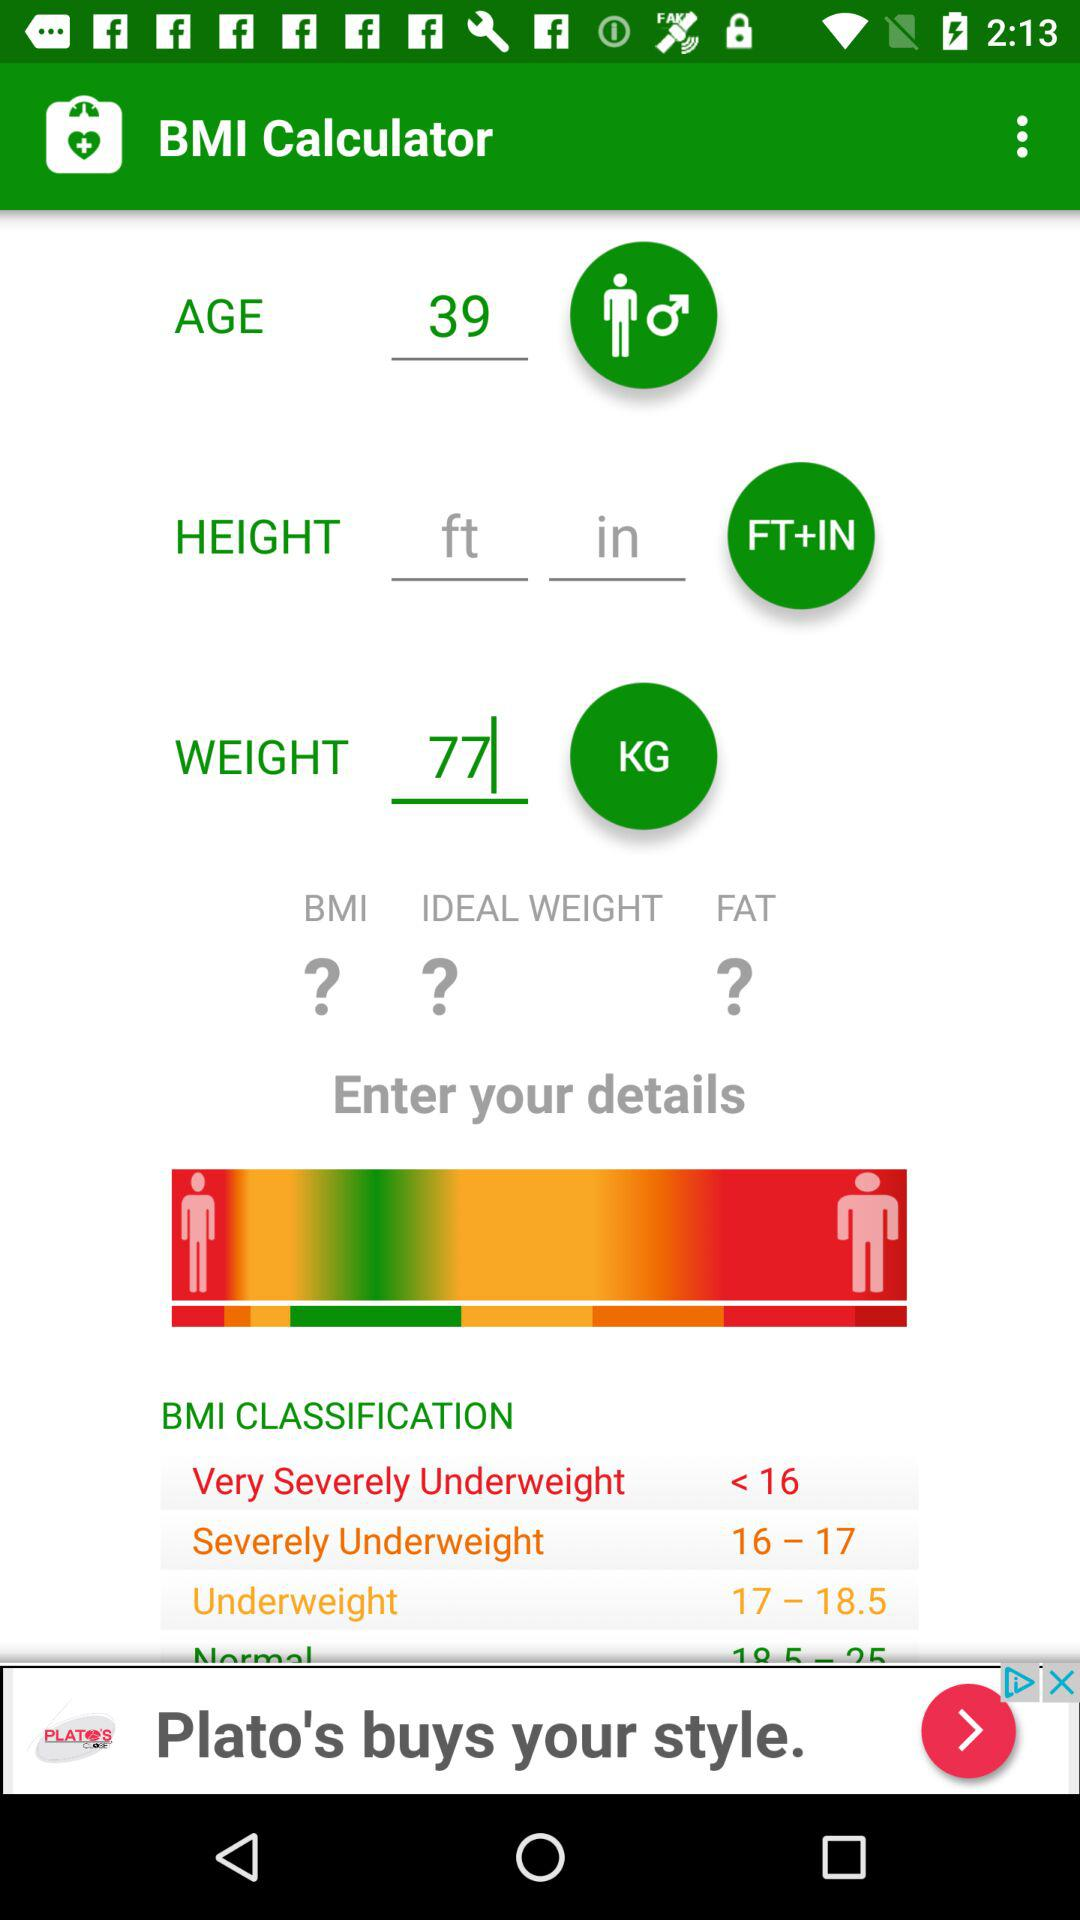What is the weight? The weight is 77 kg. 